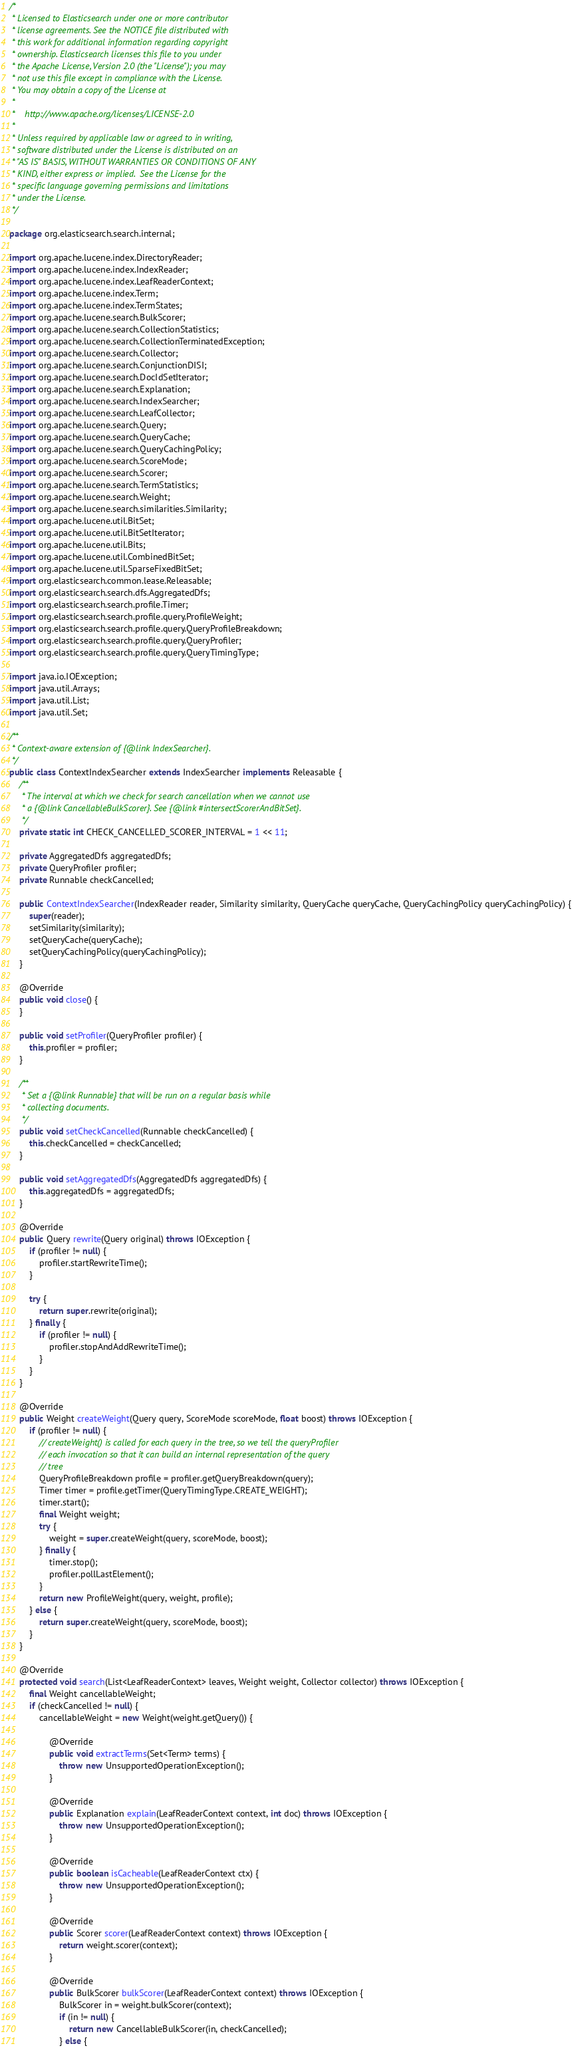Convert code to text. <code><loc_0><loc_0><loc_500><loc_500><_Java_>/*
 * Licensed to Elasticsearch under one or more contributor
 * license agreements. See the NOTICE file distributed with
 * this work for additional information regarding copyright
 * ownership. Elasticsearch licenses this file to you under
 * the Apache License, Version 2.0 (the "License"); you may
 * not use this file except in compliance with the License.
 * You may obtain a copy of the License at
 *
 *    http://www.apache.org/licenses/LICENSE-2.0
 *
 * Unless required by applicable law or agreed to in writing,
 * software distributed under the License is distributed on an
 * "AS IS" BASIS, WITHOUT WARRANTIES OR CONDITIONS OF ANY
 * KIND, either express or implied.  See the License for the
 * specific language governing permissions and limitations
 * under the License.
 */

package org.elasticsearch.search.internal;

import org.apache.lucene.index.DirectoryReader;
import org.apache.lucene.index.IndexReader;
import org.apache.lucene.index.LeafReaderContext;
import org.apache.lucene.index.Term;
import org.apache.lucene.index.TermStates;
import org.apache.lucene.search.BulkScorer;
import org.apache.lucene.search.CollectionStatistics;
import org.apache.lucene.search.CollectionTerminatedException;
import org.apache.lucene.search.Collector;
import org.apache.lucene.search.ConjunctionDISI;
import org.apache.lucene.search.DocIdSetIterator;
import org.apache.lucene.search.Explanation;
import org.apache.lucene.search.IndexSearcher;
import org.apache.lucene.search.LeafCollector;
import org.apache.lucene.search.Query;
import org.apache.lucene.search.QueryCache;
import org.apache.lucene.search.QueryCachingPolicy;
import org.apache.lucene.search.ScoreMode;
import org.apache.lucene.search.Scorer;
import org.apache.lucene.search.TermStatistics;
import org.apache.lucene.search.Weight;
import org.apache.lucene.search.similarities.Similarity;
import org.apache.lucene.util.BitSet;
import org.apache.lucene.util.BitSetIterator;
import org.apache.lucene.util.Bits;
import org.apache.lucene.util.CombinedBitSet;
import org.apache.lucene.util.SparseFixedBitSet;
import org.elasticsearch.common.lease.Releasable;
import org.elasticsearch.search.dfs.AggregatedDfs;
import org.elasticsearch.search.profile.Timer;
import org.elasticsearch.search.profile.query.ProfileWeight;
import org.elasticsearch.search.profile.query.QueryProfileBreakdown;
import org.elasticsearch.search.profile.query.QueryProfiler;
import org.elasticsearch.search.profile.query.QueryTimingType;

import java.io.IOException;
import java.util.Arrays;
import java.util.List;
import java.util.Set;

/**
 * Context-aware extension of {@link IndexSearcher}.
 */
public class ContextIndexSearcher extends IndexSearcher implements Releasable {
    /**
     * The interval at which we check for search cancellation when we cannot use
     * a {@link CancellableBulkScorer}. See {@link #intersectScorerAndBitSet}.
     */
    private static int CHECK_CANCELLED_SCORER_INTERVAL = 1 << 11;

    private AggregatedDfs aggregatedDfs;
    private QueryProfiler profiler;
    private Runnable checkCancelled;

    public ContextIndexSearcher(IndexReader reader, Similarity similarity, QueryCache queryCache, QueryCachingPolicy queryCachingPolicy) {
        super(reader);
        setSimilarity(similarity);
        setQueryCache(queryCache);
        setQueryCachingPolicy(queryCachingPolicy);
    }

    @Override
    public void close() {
    }

    public void setProfiler(QueryProfiler profiler) {
        this.profiler = profiler;
    }

    /**
     * Set a {@link Runnable} that will be run on a regular basis while
     * collecting documents.
     */
    public void setCheckCancelled(Runnable checkCancelled) {
        this.checkCancelled = checkCancelled;
    }

    public void setAggregatedDfs(AggregatedDfs aggregatedDfs) {
        this.aggregatedDfs = aggregatedDfs;
    }

    @Override
    public Query rewrite(Query original) throws IOException {
        if (profiler != null) {
            profiler.startRewriteTime();
        }

        try {
            return super.rewrite(original);
        } finally {
            if (profiler != null) {
                profiler.stopAndAddRewriteTime();
            }
        }
    }

    @Override
    public Weight createWeight(Query query, ScoreMode scoreMode, float boost) throws IOException {
        if (profiler != null) {
            // createWeight() is called for each query in the tree, so we tell the queryProfiler
            // each invocation so that it can build an internal representation of the query
            // tree
            QueryProfileBreakdown profile = profiler.getQueryBreakdown(query);
            Timer timer = profile.getTimer(QueryTimingType.CREATE_WEIGHT);
            timer.start();
            final Weight weight;
            try {
                weight = super.createWeight(query, scoreMode, boost);
            } finally {
                timer.stop();
                profiler.pollLastElement();
            }
            return new ProfileWeight(query, weight, profile);
        } else {
            return super.createWeight(query, scoreMode, boost);
        }
    }

    @Override
    protected void search(List<LeafReaderContext> leaves, Weight weight, Collector collector) throws IOException {
        final Weight cancellableWeight;
        if (checkCancelled != null) {
            cancellableWeight = new Weight(weight.getQuery()) {

                @Override
                public void extractTerms(Set<Term> terms) {
                    throw new UnsupportedOperationException();
                }

                @Override
                public Explanation explain(LeafReaderContext context, int doc) throws IOException {
                    throw new UnsupportedOperationException();
                }

                @Override
                public boolean isCacheable(LeafReaderContext ctx) {
                    throw new UnsupportedOperationException();
                }

                @Override
                public Scorer scorer(LeafReaderContext context) throws IOException {
                    return weight.scorer(context);
                }

                @Override
                public BulkScorer bulkScorer(LeafReaderContext context) throws IOException {
                    BulkScorer in = weight.bulkScorer(context);
                    if (in != null) {
                        return new CancellableBulkScorer(in, checkCancelled);
                    } else {</code> 